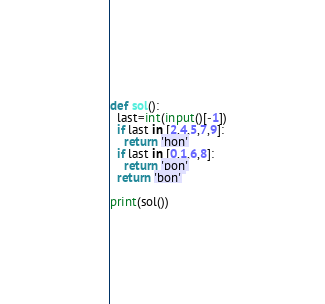Convert code to text. <code><loc_0><loc_0><loc_500><loc_500><_Python_>def sol():
  last=int(input()[-1])
  if last in [2,4,5,7,9]:
    return 'hon'
  if last in [0,1,6,8]:
    return 'pon'
  return 'bon'

print(sol())</code> 